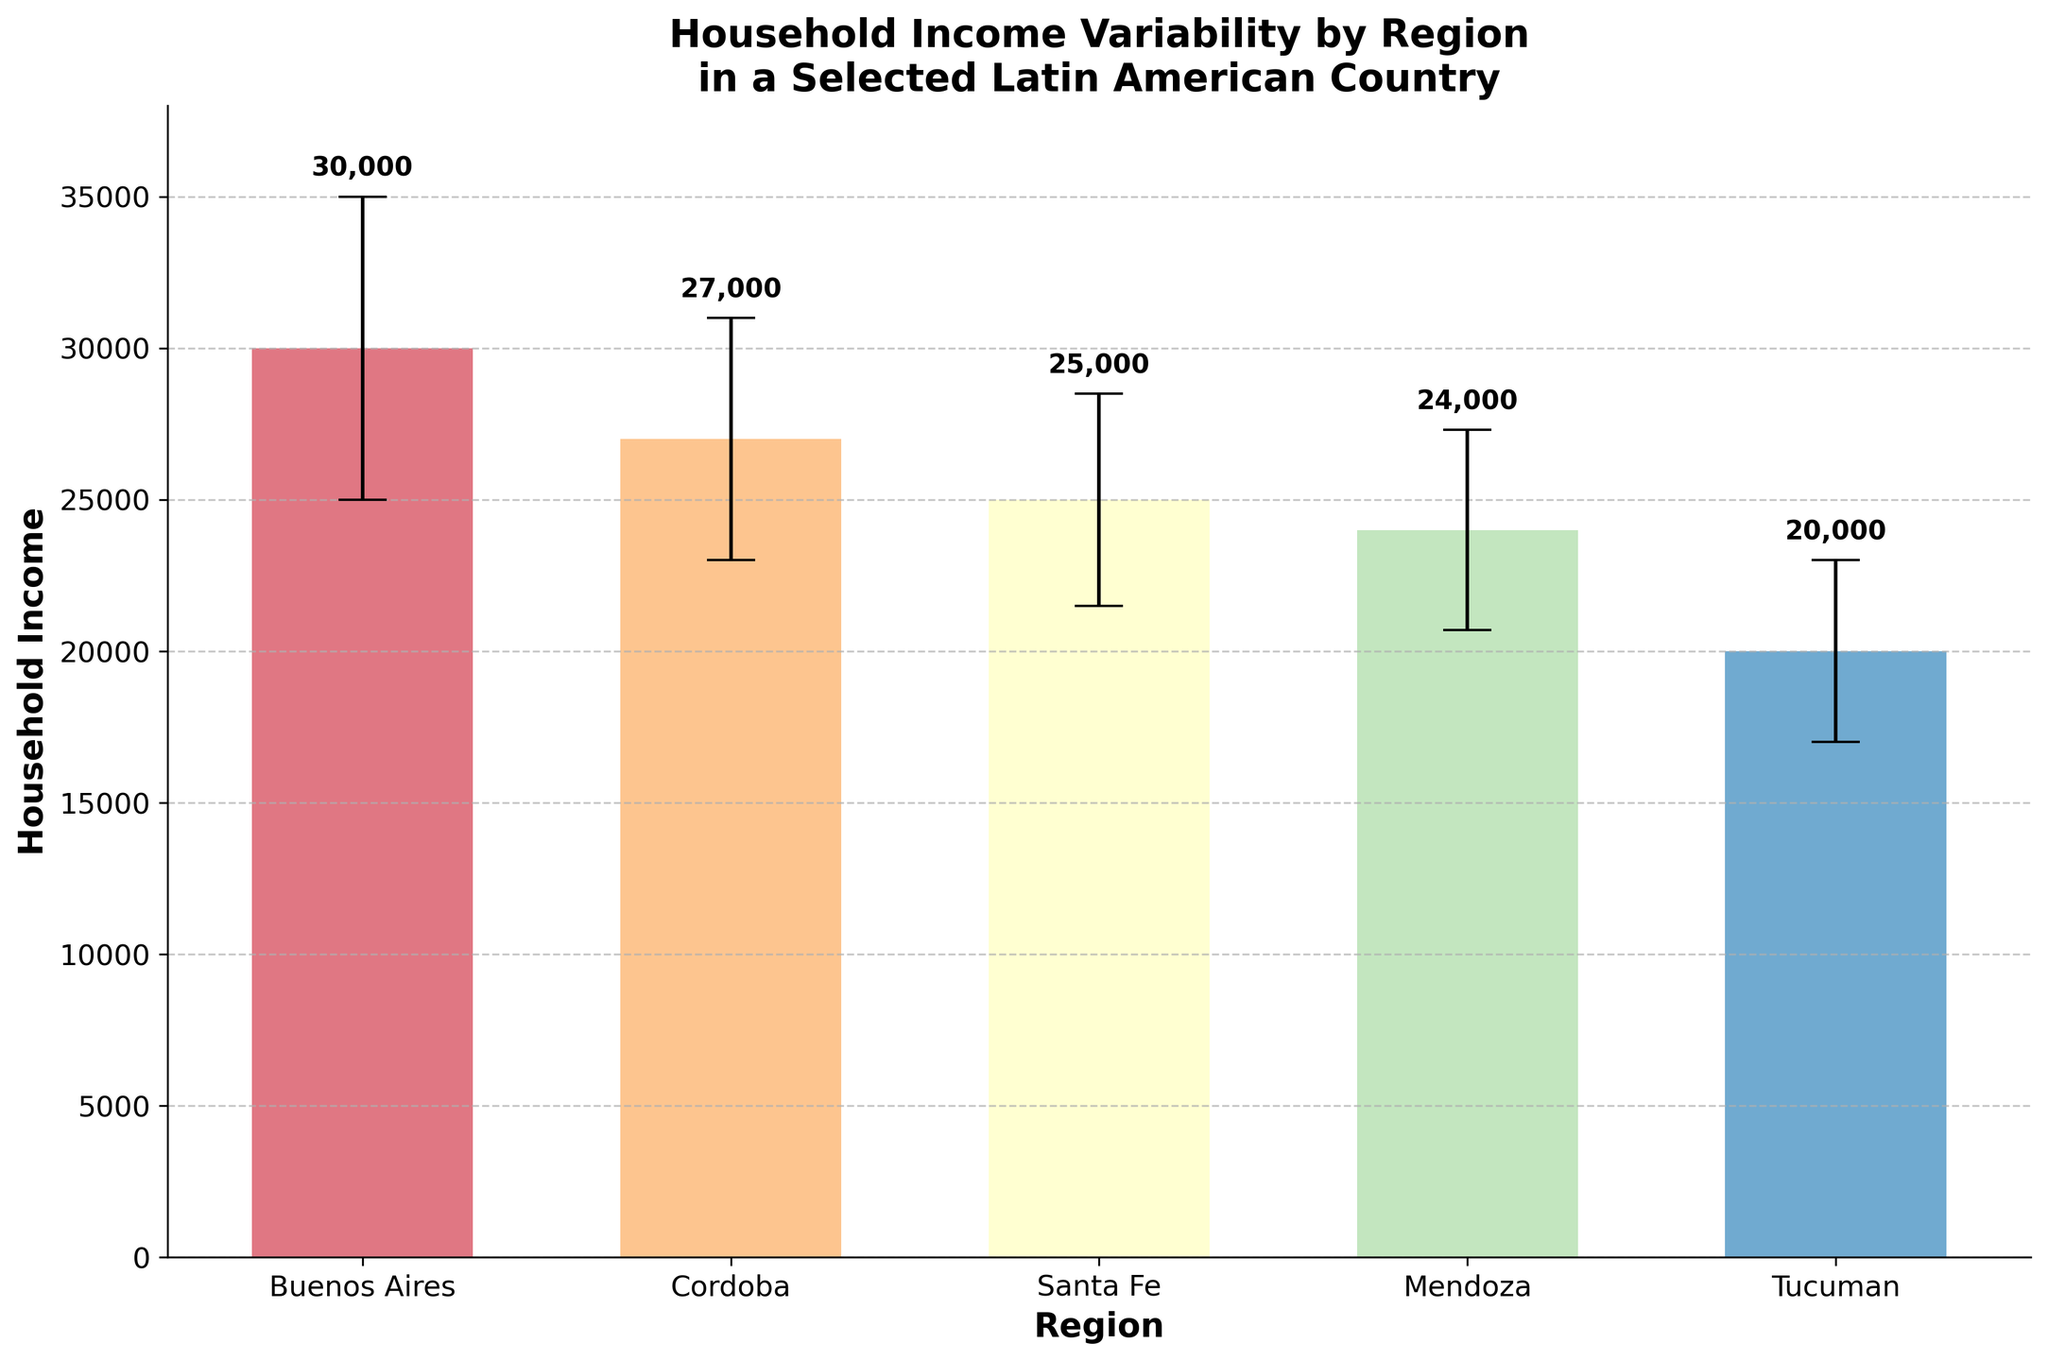What is the title of the figure? The title is located at the top of the figure and is usually in a larger and bolder font to be easily distinguishable. The title gives a summary of what the figure represents.
Answer: Household Income Variability by Region in a Selected Latin American Country Which region has the highest mean household income? Look for the tallest bar in the chart, as it represents the region with the highest mean household income.
Answer: Buenos Aires How many regions are compared in the figure? Count the number of bars in the bar plot. Each bar represents a region.
Answer: 5 Which region has the lowest mean household income, and what is the income? Identify the shortest bar on the plot. Then, read the label on the x-axis for this bar and check the value indicated.
Answer: Tucuman, 20000 What is the mean household income for Cordoba? Find the bar that represents Cordoba by looking at the x-axis labels. Read the height of the bar.
Answer: 27000 What is the difference in mean household income between Buenos Aires and Tucuman? Find the mean household incomes for Buenos Aires and Tucuman. Subtract the mean income of Tucuman from the mean income of Buenos Aires.
Answer: 10000 Which region has the largest variability in household income? Look for the bar with the longest error bar, which indicates the largest standard deviation.
Answer: Buenos Aires Compare the mean household incomes of Santa Fe and Mendoza. Which is higher and by how much? Identify and compare the heights of the bars for Santa Fe and Mendoza, and then find the difference between the two.
Answer: Santa Fe by 1000 What does the y-axis represent in this figure? The y-axis label is usually located along the vertical axis and specifies what is being measured.
Answer: Household Income How does the variability in income for Tucuman compare to Cordoba? Compare the lengths of the error bars for Tucuman and Cordoba. Longer error bars indicate higher variability.
Answer: Tucuman has less variability than Cordoba 